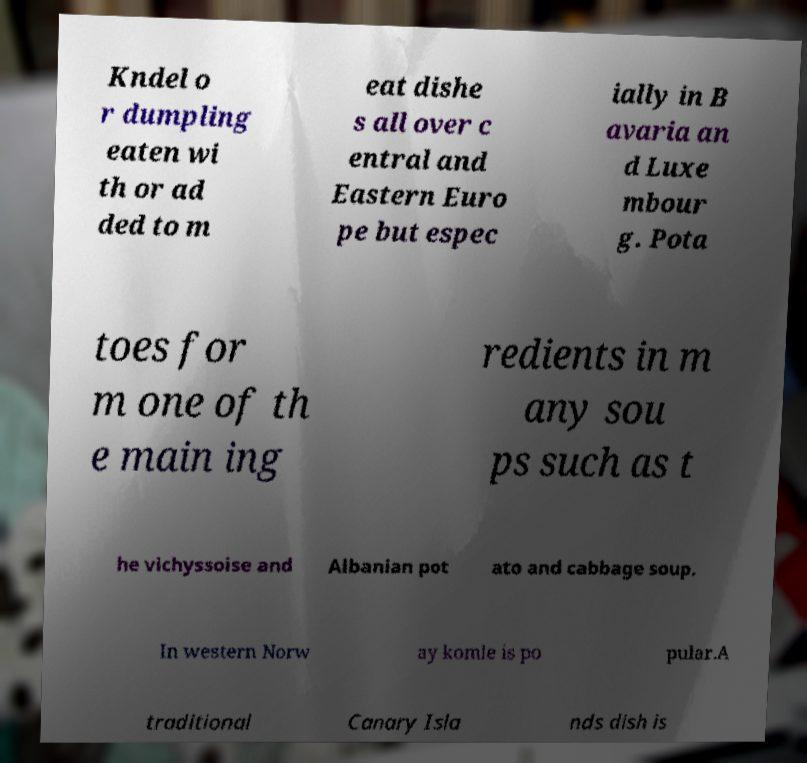Could you extract and type out the text from this image? Kndel o r dumpling eaten wi th or ad ded to m eat dishe s all over c entral and Eastern Euro pe but espec ially in B avaria an d Luxe mbour g. Pota toes for m one of th e main ing redients in m any sou ps such as t he vichyssoise and Albanian pot ato and cabbage soup. In western Norw ay komle is po pular.A traditional Canary Isla nds dish is 